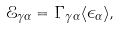<formula> <loc_0><loc_0><loc_500><loc_500>\mathcal { E } _ { \gamma \alpha } = \Gamma _ { \gamma \alpha } \langle \epsilon _ { \alpha } \rangle ,</formula> 